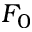Convert formula to latex. <formula><loc_0><loc_0><loc_500><loc_500>F _ { 0 }</formula> 